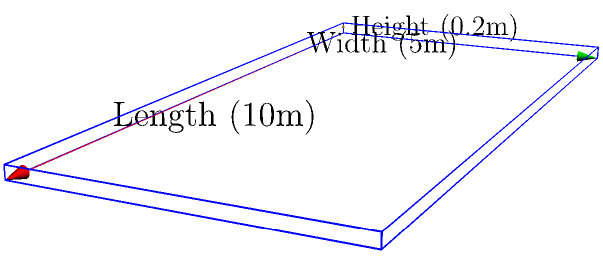A new rectangular prism-shaped running track is being constructed for training purposes. The track measures 10 meters in length, 5 meters in width, and has a height of 0.2 meters. Calculate the volume of material needed to fill this track, assuming it will be filled completely. To find the volume of a rectangular prism, we use the formula:

$$V = l \times w \times h$$

Where:
$V$ = Volume
$l$ = Length
$w$ = Width
$h$ = Height

Given:
- Length $(l) = 10$ meters
- Width $(w) = 5$ meters
- Height $(h) = 0.2$ meters

Let's substitute these values into the formula:

$$V = 10 \text{ m} \times 5 \text{ m} \times 0.2 \text{ m}$$

Now, let's calculate:

$$V = 10 \times 5 \times 0.2 = 10 \text{ m}^3$$

Therefore, the volume of material needed to fill the track is 10 cubic meters.
Answer: $10 \text{ m}^3$ 